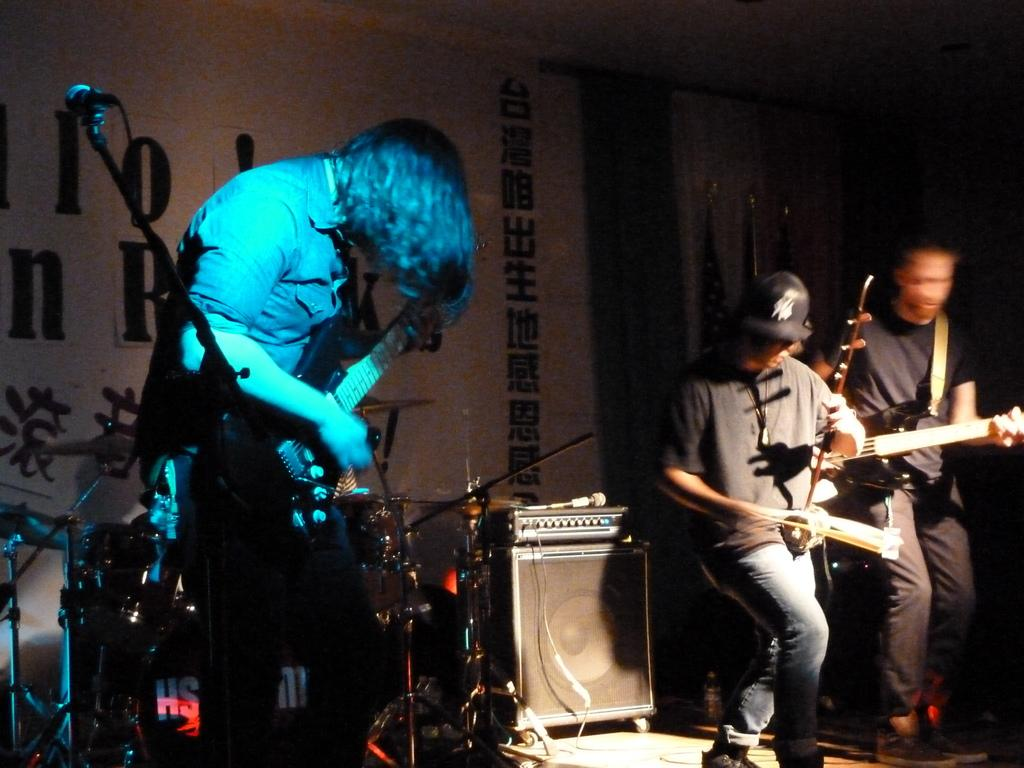How many people are in the image? There are three people in the image. What are the people doing in the image? The three people are playing musical instruments. What can be seen in the background of the image? There is a banner and flags in the background of the image. Can you see any jellyfish swimming in the image? No, there are no jellyfish present in the image. What type of toy is being played with by the people in the image? The people in the image are playing musical instruments, not toys. 